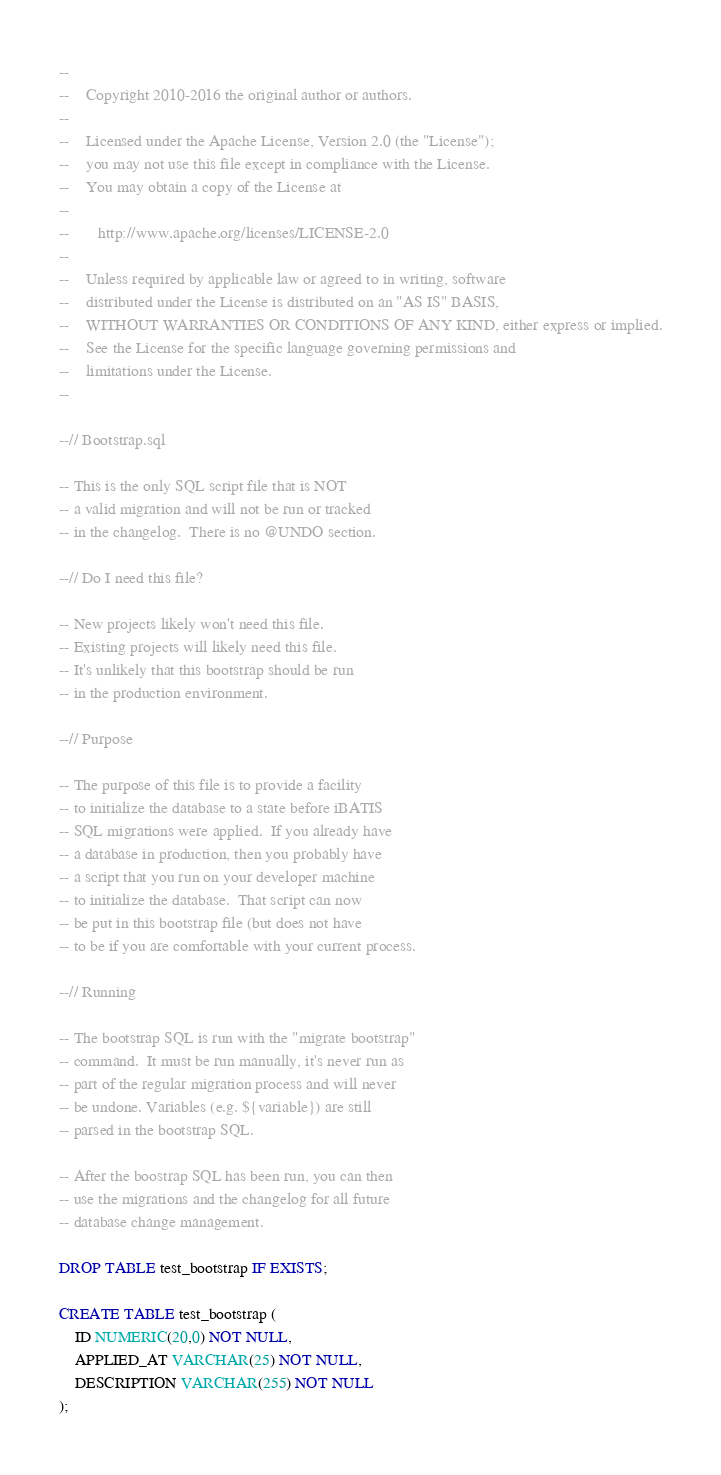Convert code to text. <code><loc_0><loc_0><loc_500><loc_500><_SQL_>--
--    Copyright 2010-2016 the original author or authors.
--
--    Licensed under the Apache License, Version 2.0 (the "License");
--    you may not use this file except in compliance with the License.
--    You may obtain a copy of the License at
--
--       http://www.apache.org/licenses/LICENSE-2.0
--
--    Unless required by applicable law or agreed to in writing, software
--    distributed under the License is distributed on an "AS IS" BASIS,
--    WITHOUT WARRANTIES OR CONDITIONS OF ANY KIND, either express or implied.
--    See the License for the specific language governing permissions and
--    limitations under the License.
--

--// Bootstrap.sql

-- This is the only SQL script file that is NOT
-- a valid migration and will not be run or tracked
-- in the changelog.  There is no @UNDO section.

--// Do I need this file?

-- New projects likely won't need this file.
-- Existing projects will likely need this file.
-- It's unlikely that this bootstrap should be run
-- in the production environment.

--// Purpose

-- The purpose of this file is to provide a facility
-- to initialize the database to a state before iBATIS
-- SQL migrations were applied.  If you already have
-- a database in production, then you probably have
-- a script that you run on your developer machine
-- to initialize the database.  That script can now
-- be put in this bootstrap file (but does not have
-- to be if you are comfortable with your current process.

--// Running

-- The bootstrap SQL is run with the "migrate bootstrap"
-- command.  It must be run manually, it's never run as
-- part of the regular migration process and will never
-- be undone. Variables (e.g. ${variable}) are still
-- parsed in the bootstrap SQL.

-- After the boostrap SQL has been run, you can then
-- use the migrations and the changelog for all future
-- database change management.

DROP TABLE test_bootstrap IF EXISTS;

CREATE TABLE test_bootstrap (
    ID NUMERIC(20,0) NOT NULL,
    APPLIED_AT VARCHAR(25) NOT NULL,
    DESCRIPTION VARCHAR(255) NOT NULL
);
</code> 